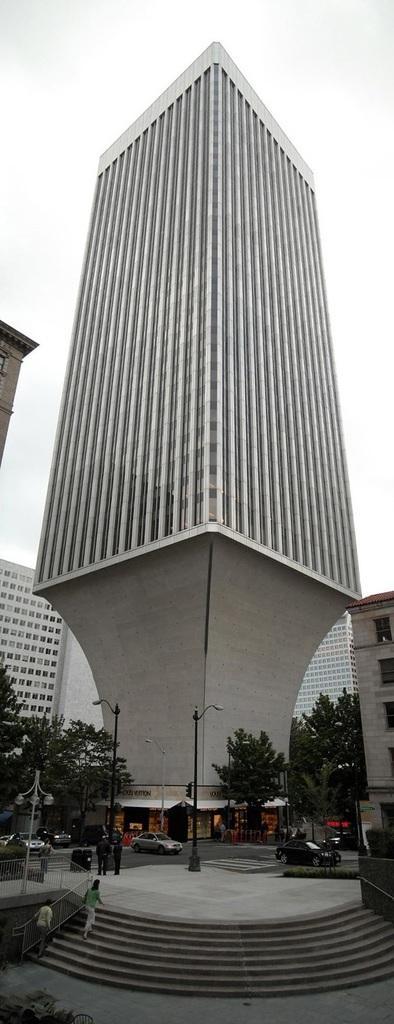How would you summarize this image in a sentence or two? There are persons, cars and trees and trees are present at the bottom of this image. We can see buildings in the middle of this image and the sky is in the background. 